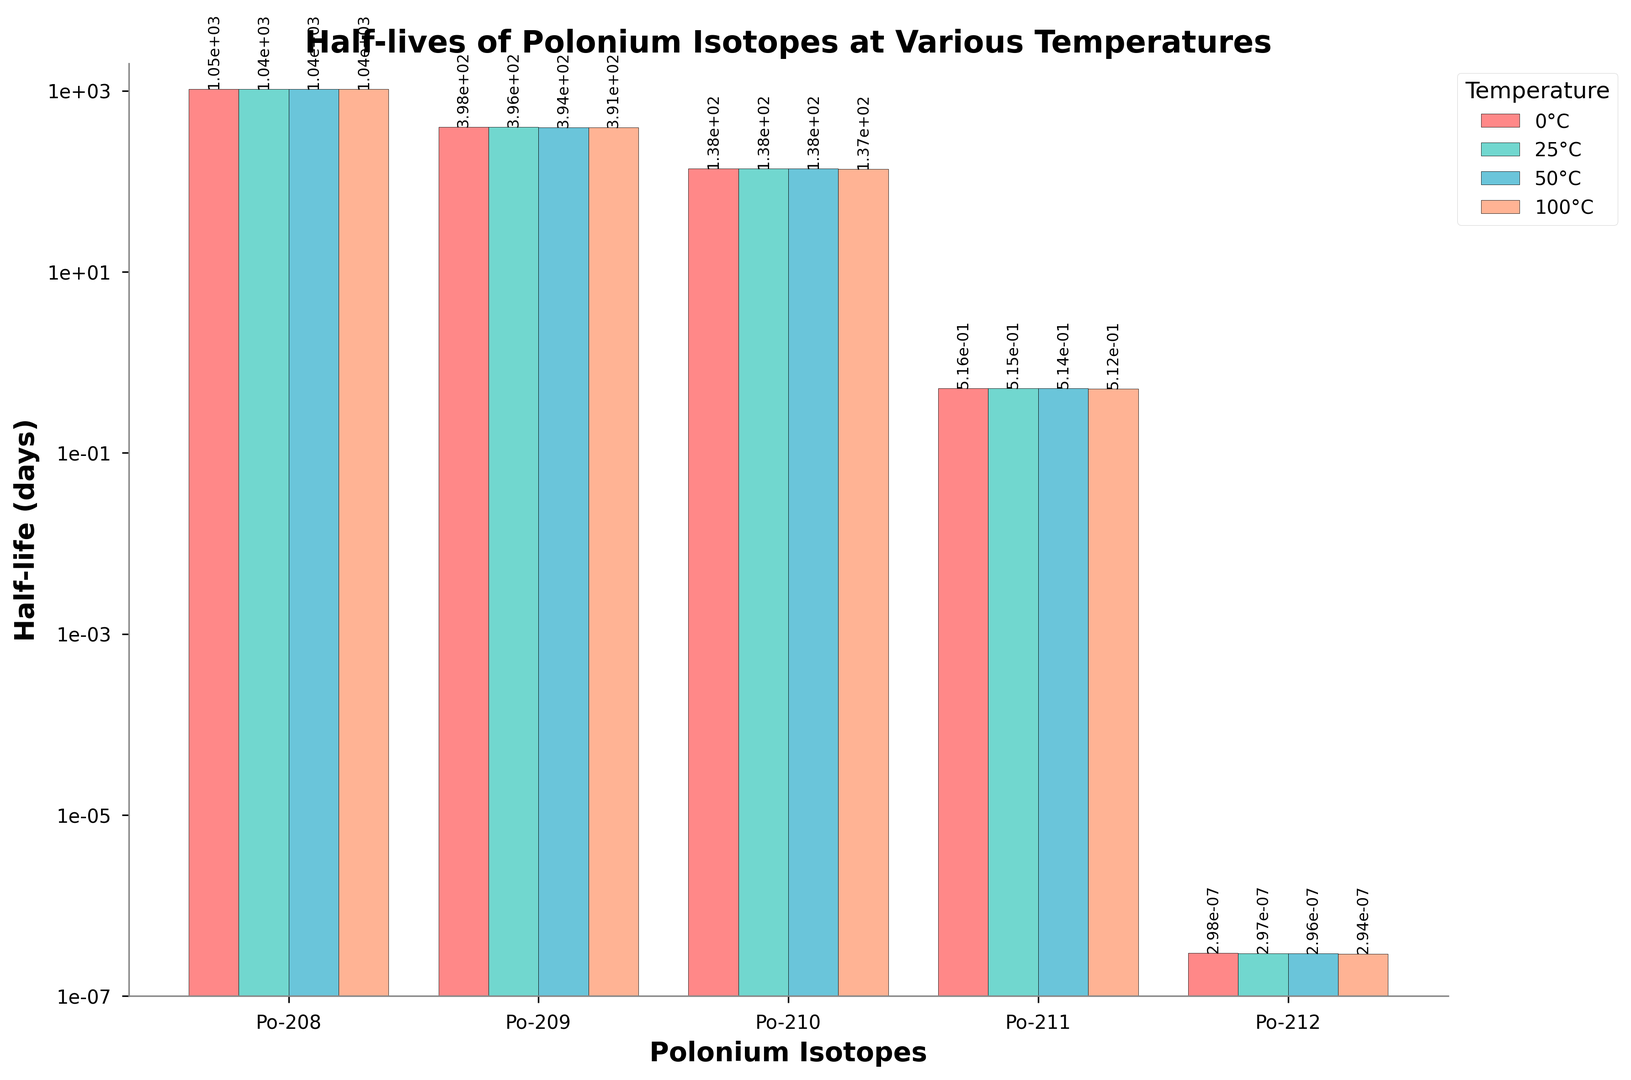Which polonium isotope has the longest half-life at 0°C? Look at the bars representing 0°C across the different isotopes and identify the tallest one. Po-208 has the largest value of 1048 days.
Answer: Po-208 How does the half-life of Po-209 change from 0°C to 100°C? Compare the height of the Po-209 bar at 0°C and 100°C. The value decreases from 398 days at 0°C to 391 days at 100°C.
Answer: Decreases Which temperature condition shows the largest difference in half-life between Po-210 and Po-211? Calculate the difference in half-life between Po-210 and Po-211 at each temperature and identify the maximum difference. At 0°C, the difference is 138.4 - 0.516 = 137.884 days, which is the largest.
Answer: 0°C Are there any temperatures where the half-life of Po-210 is exactly double that of Po-211? Double Po-211's half-life at each temperature and see if it matches Po-210's half-life. Doubling any half-life of Po-211 (0.516, 0.515, 0.514, 0.512) does not match Po-210's values (138.4, 138.0, 137.6, 136.8).
Answer: No Which temperature shows the smallest change in half-life for Po-212 compared to 0°C? Calculate the absolute differences between the half-life at each temperature and 0°C for Po-212. 25°C has the smallest change, with an absolute difference of 0.000000298 - 0.000000297 = 0.000000001.
Answer: 25°C Is there any isotope whose half-life remains almost constant across all temperatures? Check each isotope's half-life across all temperatures for minimal changes. Po-211 shows very small changes (0.516 to 0.512 days), indicating near constancy.
Answer: Po-211 Which isotope has the steepest decrease in half-life as temperature increases from 0°C to 100°C? Calculate the difference in half-life from 0°C to 100°C for each isotope. Po-208 shows the steepest decrease, from 1048 to 1038 days, a difference of 10 days.
Answer: Po-208 How does the half-life of Po-212 at 50°C compare visually to its half-life at 0°C? Observe the bar heights for Po-212 at 50°C and 0°C. The bar at 50°C is slightly shorter than at 0°C, indicating a small decrease from 0.000000298 to 0.000000296.
Answer: Slightly shorter 